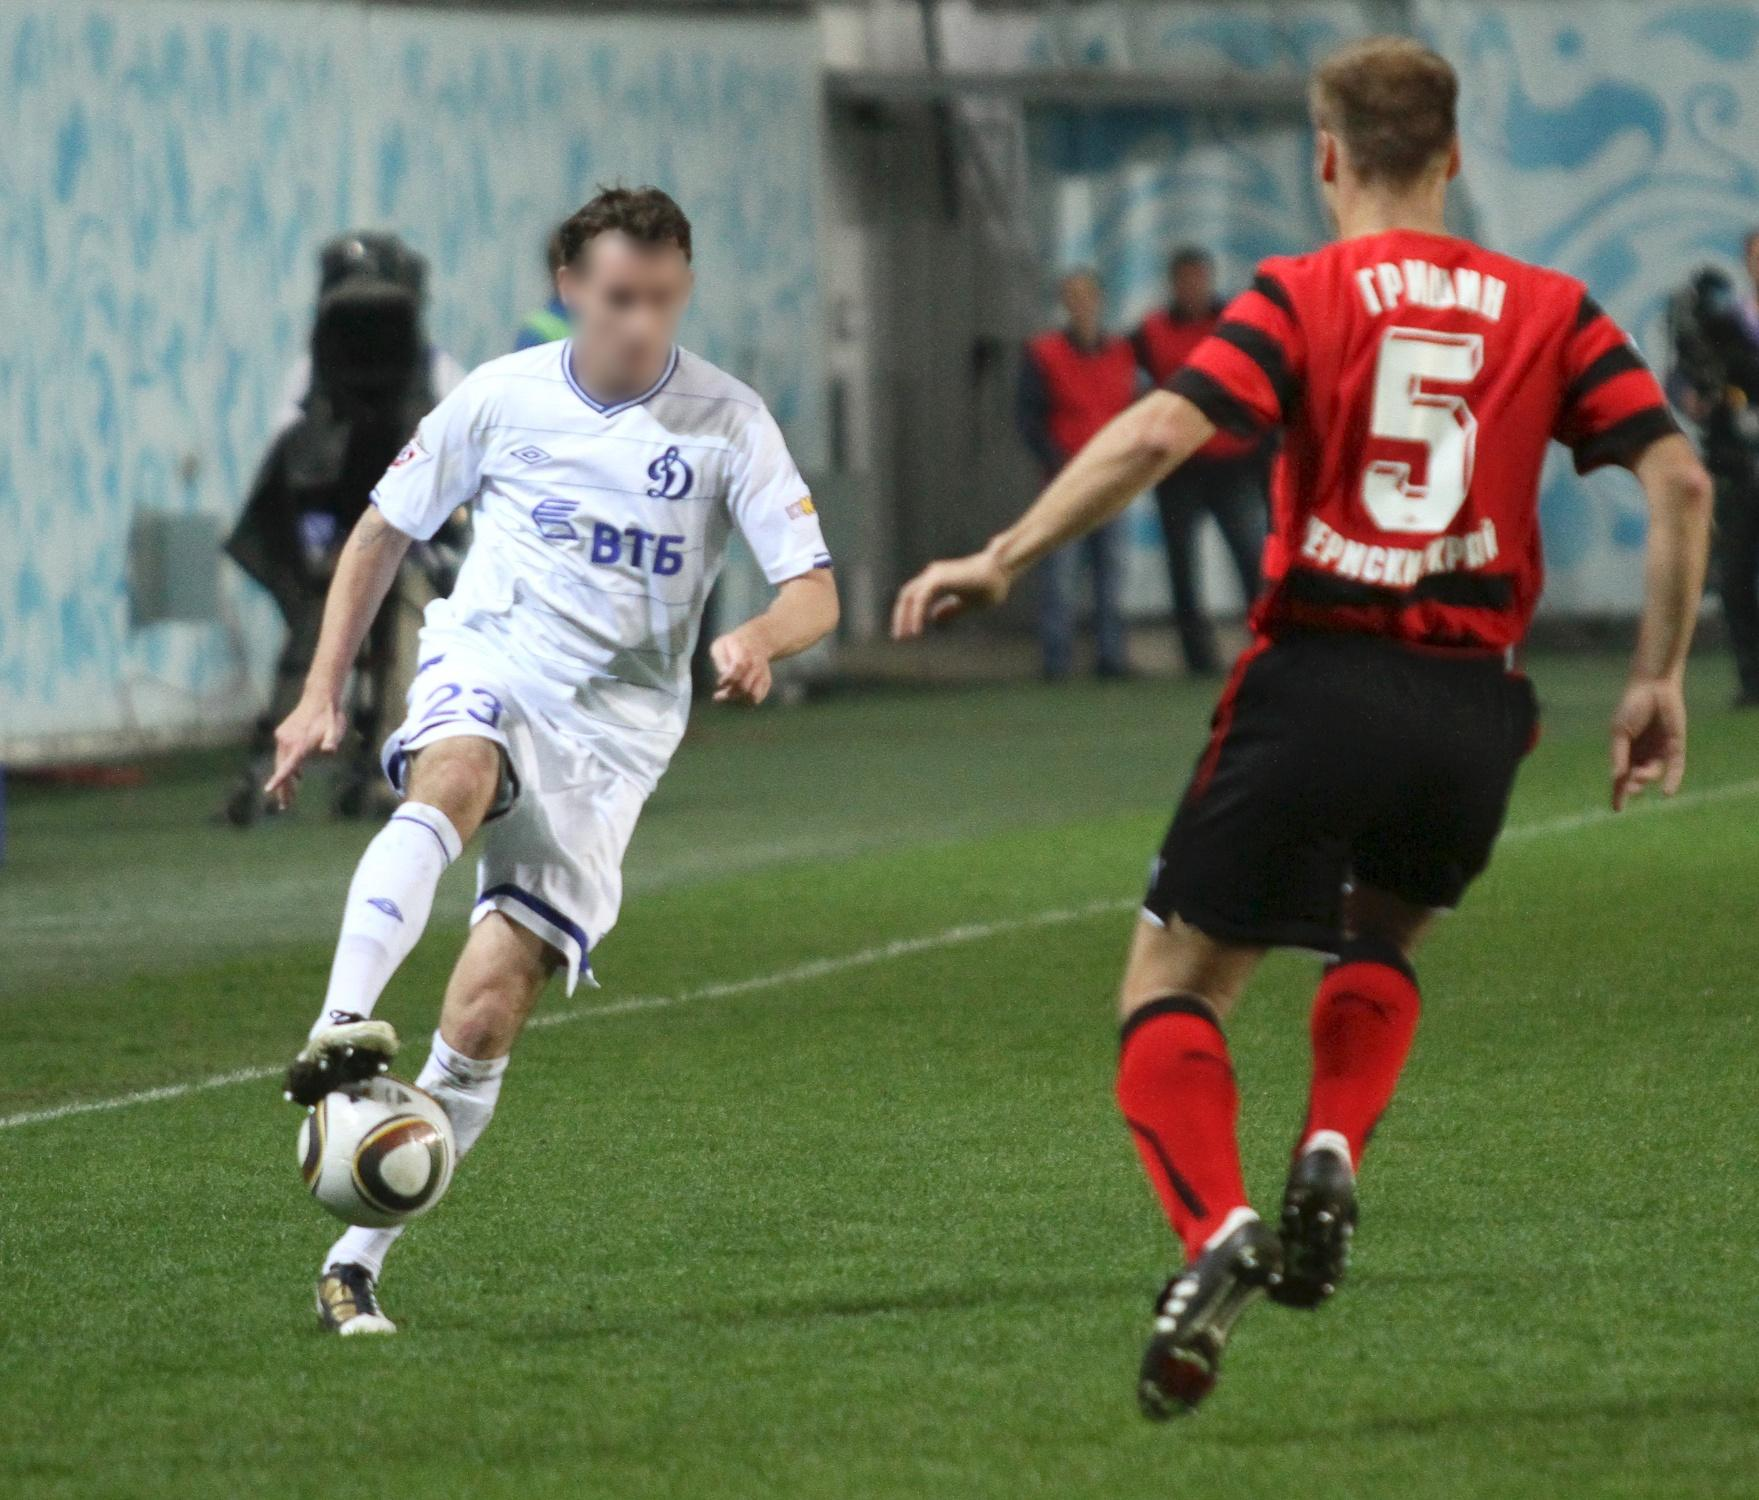Write a short poem inspired by this image. In the heart of blue and white,
On fields of green so bright,
Two souls embrace the fight,
Chasing dreams in flight.

A blur of motion, fierce and keen,
In shades of red and white, they gleam,
Within the stadium's azure sheen,
They dance a warrior's dream.

Cheers and roars fuel the night,
A symphony of pure delight,
In a world where hopes ignite,
Underneath the floodlit light. 